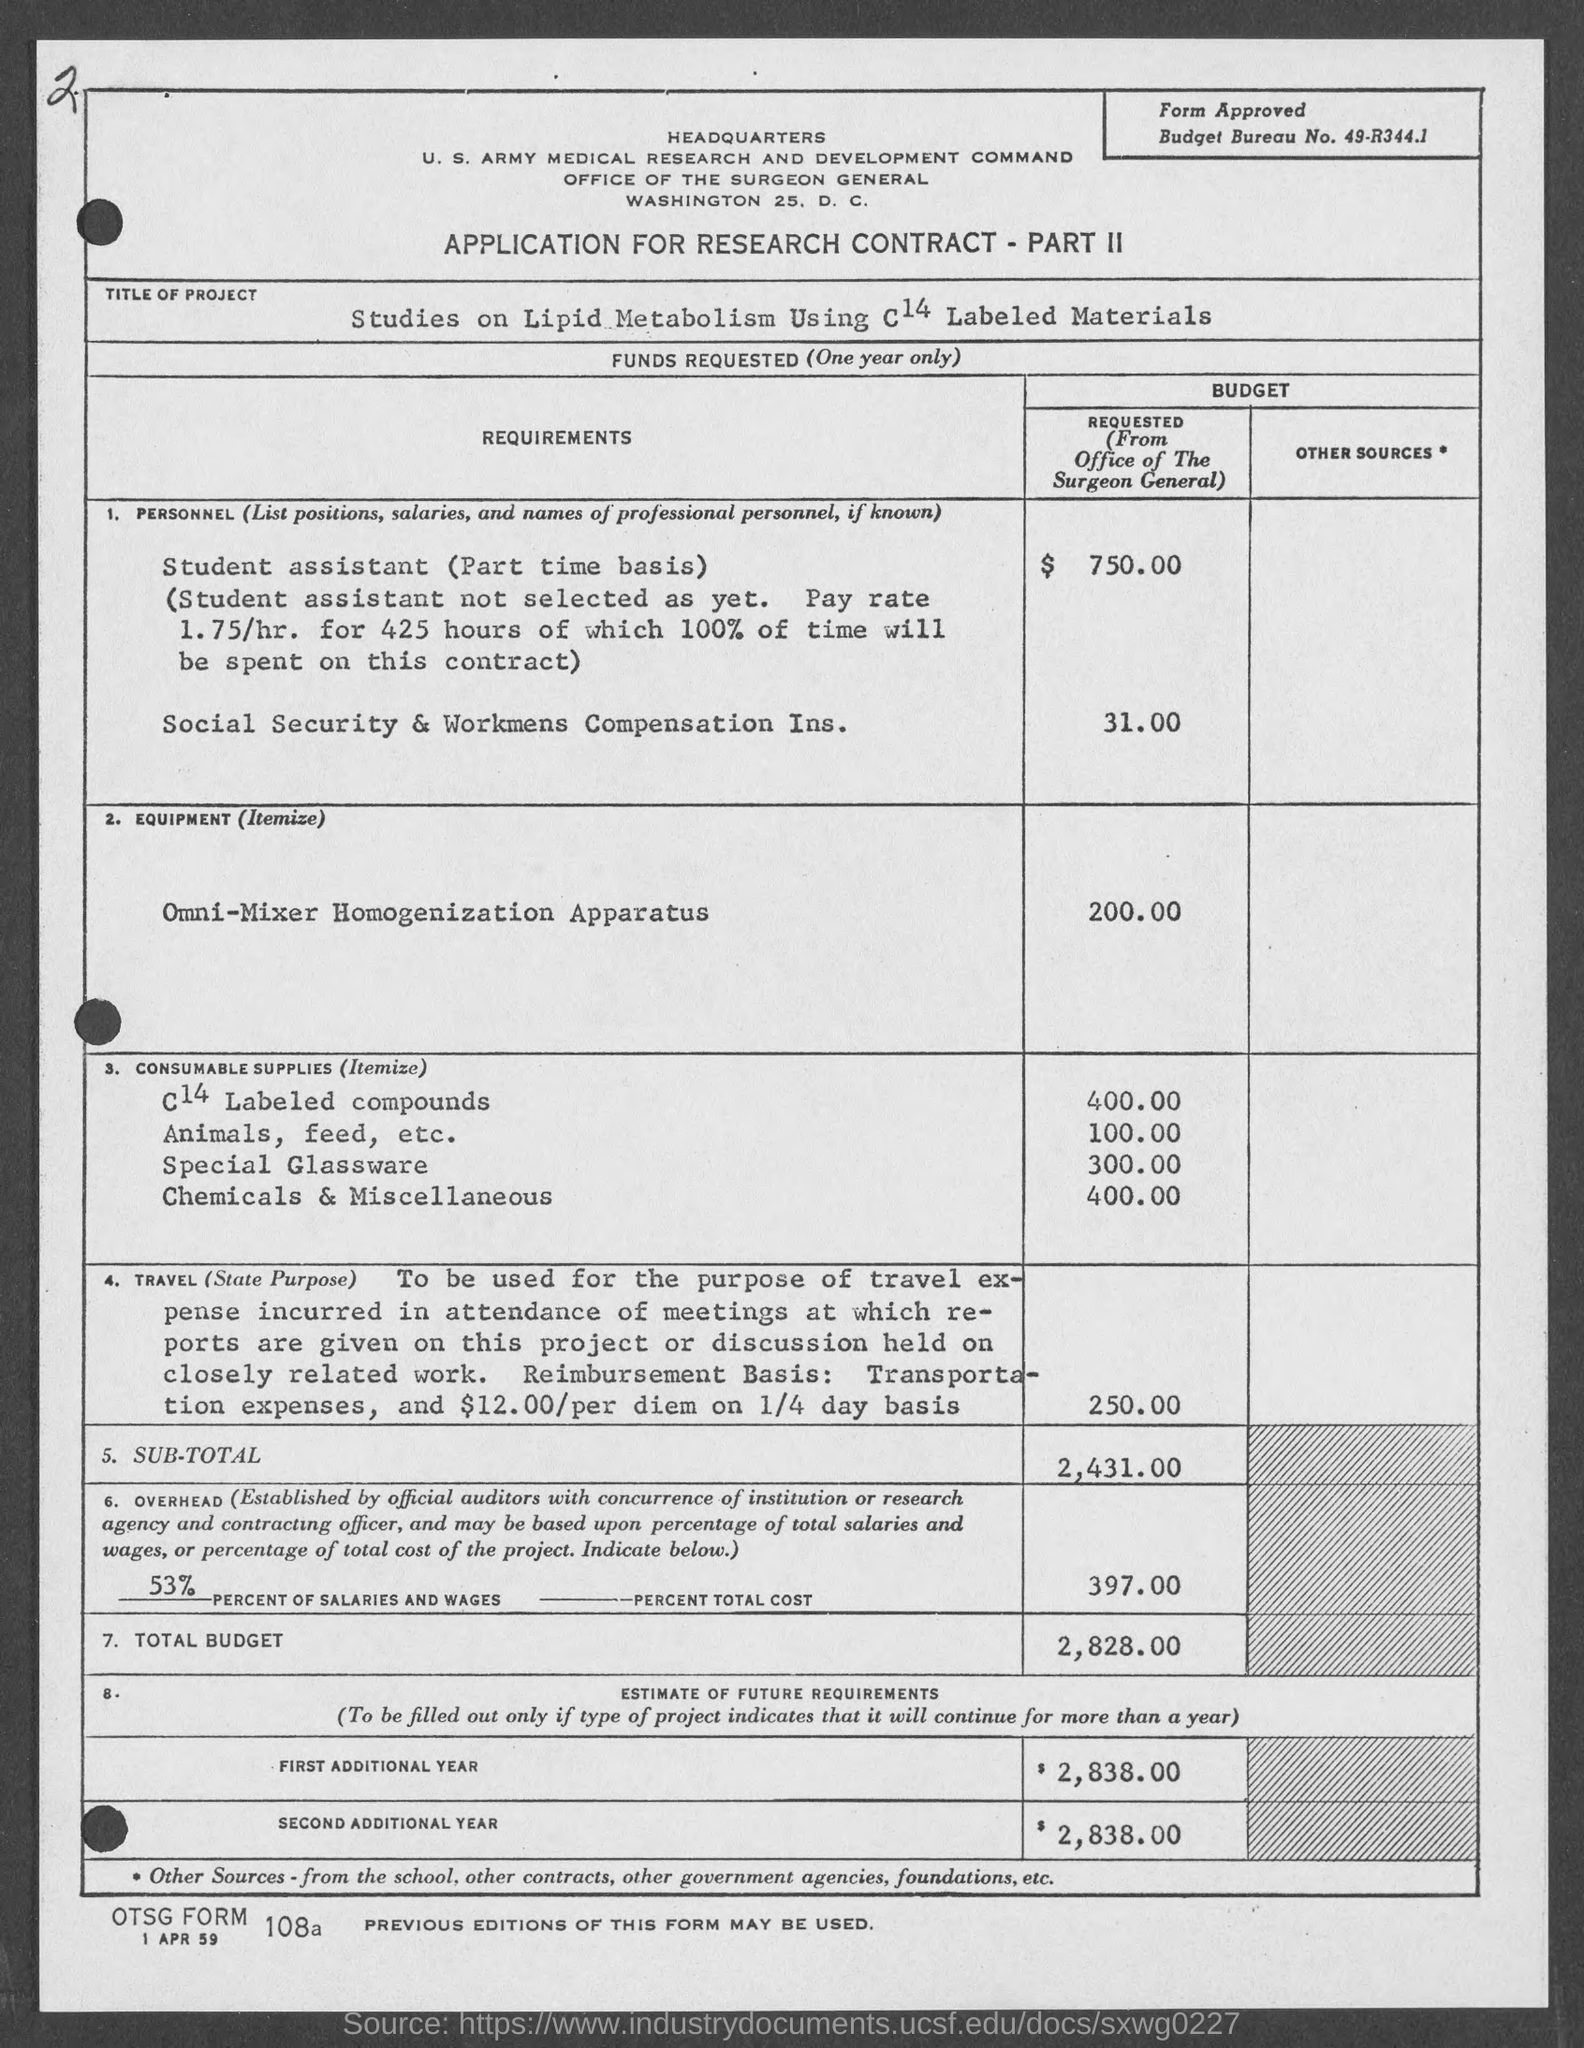Point out several critical features in this image. The requested budget for the Omni-Mixer Homogenization Apparatus is $200.00. The total budget requested from the Office of the Surgeon General is $2,828.00. The budget requested for Social Security and Workers' Compensation Insurance is $31.00. The application provided is for a research contract. 